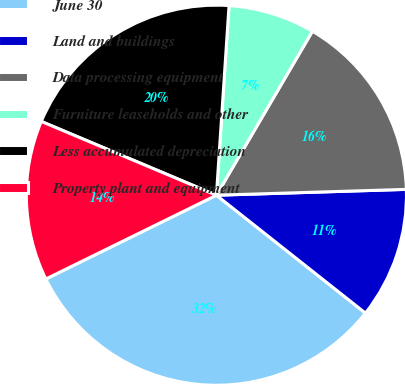Convert chart. <chart><loc_0><loc_0><loc_500><loc_500><pie_chart><fcel>June 30<fcel>Land and buildings<fcel>Data processing equipment<fcel>Furniture leaseholds and other<fcel>Less accumulated depreciation<fcel>Property plant and equipment<nl><fcel>32.08%<fcel>11.14%<fcel>16.08%<fcel>7.37%<fcel>19.71%<fcel>13.61%<nl></chart> 